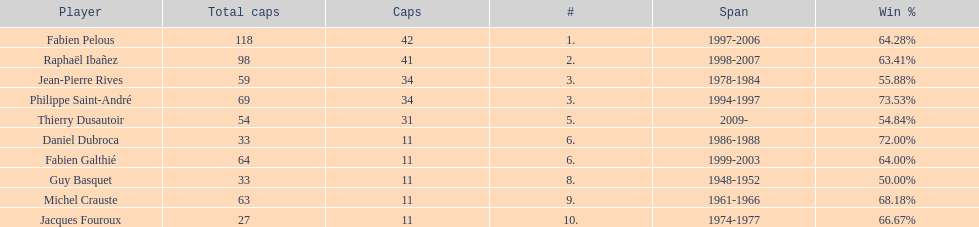How long did fabien pelous serve as captain in the french national rugby team? 9 years. 